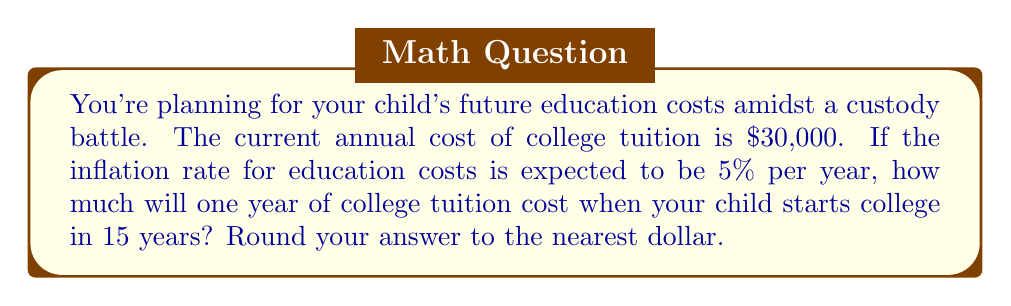Solve this math problem. To solve this problem, we need to use the compound interest formula, as the inflation rate compounds annually. The formula is:

$$A = P(1 + r)^n$$

Where:
$A$ = Final amount
$P$ = Principal (initial amount)
$r$ = Annual interest rate (in decimal form)
$n$ = Number of years

Given:
$P = \$30,000$ (current annual tuition cost)
$r = 0.05$ (5% inflation rate in decimal form)
$n = 15$ years

Let's plug these values into the formula:

$$A = 30,000(1 + 0.05)^{15}$$

Now, let's calculate:

$$\begin{align*}
A &= 30,000(1.05)^{15} \\
&= 30,000(2.0789) \\
&= 62,367
\end{align*}$$

Rounding to the nearest dollar, we get $62,367.
Answer: $62,367 